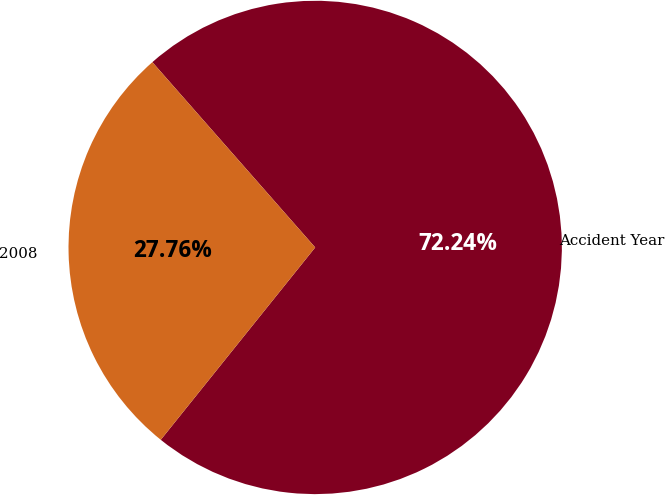Convert chart to OTSL. <chart><loc_0><loc_0><loc_500><loc_500><pie_chart><fcel>Accident Year<fcel>2008<nl><fcel>72.24%<fcel>27.76%<nl></chart> 